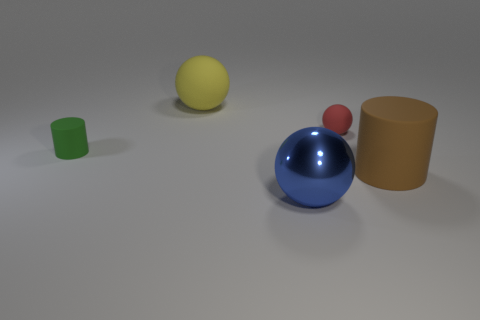There is a rubber sphere that is the same size as the blue metal sphere; what color is it?
Offer a very short reply. Yellow. Does the matte cylinder in front of the green rubber cylinder have the same size as the rubber sphere to the left of the shiny thing?
Provide a short and direct response. Yes. There is a thing that is both to the left of the large brown thing and to the right of the metal object; what is its material?
Your answer should be very brief. Rubber. How many other objects are there of the same size as the blue sphere?
Your answer should be very brief. 2. There is a large object that is behind the large rubber cylinder; what is it made of?
Give a very brief answer. Rubber. Is the shape of the tiny red rubber object the same as the yellow object?
Make the answer very short. Yes. How many other things are the same shape as the green rubber thing?
Give a very brief answer. 1. The big thing behind the tiny green matte object is what color?
Your response must be concise. Yellow. Is the blue sphere the same size as the yellow ball?
Offer a terse response. Yes. What is the material of the small thing in front of the small rubber object behind the small matte cylinder?
Your answer should be very brief. Rubber. 